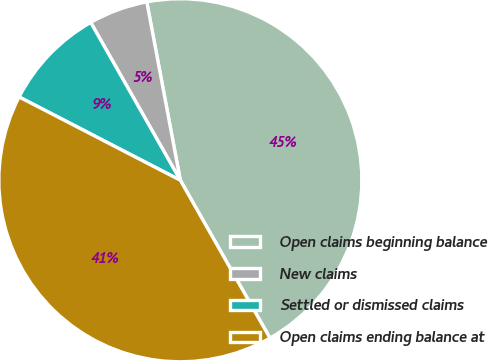Convert chart to OTSL. <chart><loc_0><loc_0><loc_500><loc_500><pie_chart><fcel>Open claims beginning balance<fcel>New claims<fcel>Settled or dismissed claims<fcel>Open claims ending balance at<nl><fcel>44.74%<fcel>5.26%<fcel>9.19%<fcel>40.81%<nl></chart> 